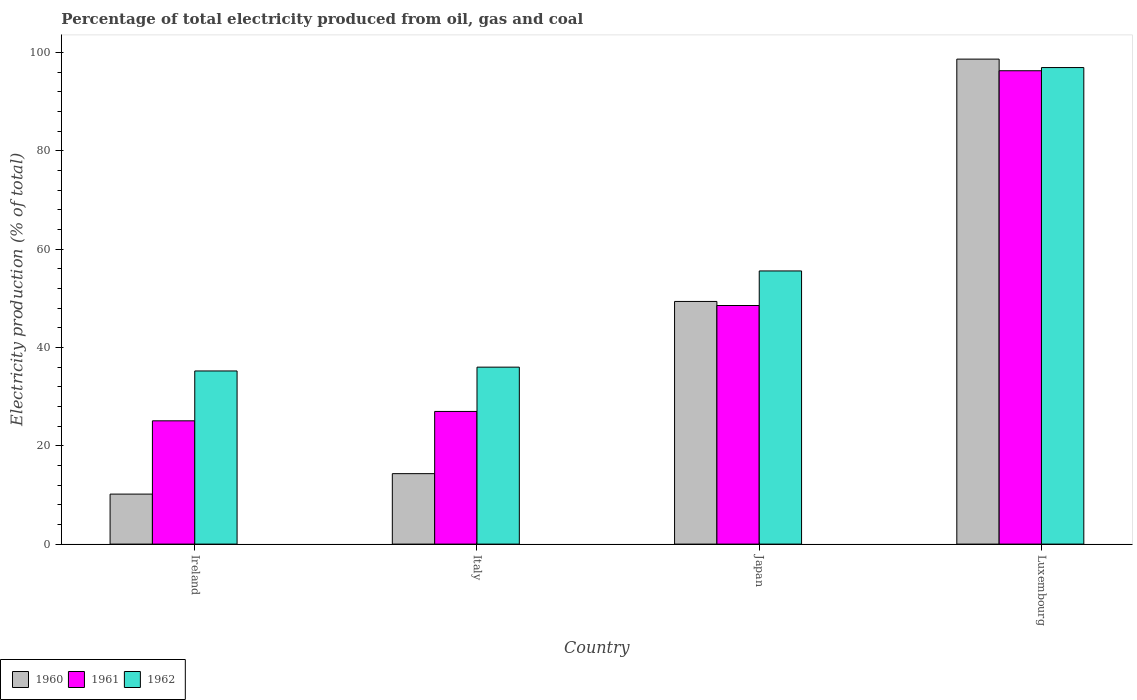How many different coloured bars are there?
Ensure brevity in your answer.  3. How many groups of bars are there?
Make the answer very short. 4. Are the number of bars on each tick of the X-axis equal?
Provide a short and direct response. Yes. What is the electricity production in in 1962 in Luxembourg?
Give a very brief answer. 96.92. Across all countries, what is the maximum electricity production in in 1961?
Your answer should be very brief. 96.27. Across all countries, what is the minimum electricity production in in 1961?
Make the answer very short. 25.07. In which country was the electricity production in in 1962 maximum?
Ensure brevity in your answer.  Luxembourg. In which country was the electricity production in in 1961 minimum?
Give a very brief answer. Ireland. What is the total electricity production in in 1960 in the graph?
Make the answer very short. 172.48. What is the difference between the electricity production in in 1961 in Ireland and that in Luxembourg?
Offer a terse response. -71.2. What is the difference between the electricity production in in 1960 in Japan and the electricity production in in 1961 in Ireland?
Ensure brevity in your answer.  24.28. What is the average electricity production in in 1962 per country?
Keep it short and to the point. 55.92. What is the difference between the electricity production in of/in 1961 and electricity production in of/in 1962 in Ireland?
Your response must be concise. -10.14. In how many countries, is the electricity production in in 1962 greater than 44 %?
Provide a succinct answer. 2. What is the ratio of the electricity production in in 1962 in Ireland to that in Luxembourg?
Keep it short and to the point. 0.36. Is the electricity production in in 1960 in Ireland less than that in Luxembourg?
Provide a short and direct response. Yes. What is the difference between the highest and the second highest electricity production in in 1962?
Make the answer very short. 60.93. What is the difference between the highest and the lowest electricity production in in 1960?
Provide a short and direct response. 88.47. Is the sum of the electricity production in in 1960 in Italy and Japan greater than the maximum electricity production in in 1961 across all countries?
Provide a short and direct response. No. What does the 3rd bar from the left in Luxembourg represents?
Your answer should be compact. 1962. What does the 3rd bar from the right in Luxembourg represents?
Ensure brevity in your answer.  1960. Are all the bars in the graph horizontal?
Your response must be concise. No. Does the graph contain grids?
Offer a very short reply. No. What is the title of the graph?
Provide a succinct answer. Percentage of total electricity produced from oil, gas and coal. Does "1972" appear as one of the legend labels in the graph?
Offer a terse response. No. What is the label or title of the Y-axis?
Provide a short and direct response. Electricity production (% of total). What is the Electricity production (% of total) in 1960 in Ireland?
Your answer should be very brief. 10.17. What is the Electricity production (% of total) of 1961 in Ireland?
Provide a short and direct response. 25.07. What is the Electricity production (% of total) in 1962 in Ireland?
Your answer should be compact. 35.21. What is the Electricity production (% of total) of 1960 in Italy?
Make the answer very short. 14.33. What is the Electricity production (% of total) in 1961 in Italy?
Make the answer very short. 26.98. What is the Electricity production (% of total) in 1962 in Italy?
Give a very brief answer. 35.99. What is the Electricity production (% of total) in 1960 in Japan?
Offer a terse response. 49.35. What is the Electricity production (% of total) of 1961 in Japan?
Provide a succinct answer. 48.52. What is the Electricity production (% of total) in 1962 in Japan?
Your response must be concise. 55.56. What is the Electricity production (% of total) in 1960 in Luxembourg?
Your answer should be compact. 98.63. What is the Electricity production (% of total) of 1961 in Luxembourg?
Ensure brevity in your answer.  96.27. What is the Electricity production (% of total) of 1962 in Luxembourg?
Offer a very short reply. 96.92. Across all countries, what is the maximum Electricity production (% of total) of 1960?
Make the answer very short. 98.63. Across all countries, what is the maximum Electricity production (% of total) of 1961?
Your answer should be very brief. 96.27. Across all countries, what is the maximum Electricity production (% of total) in 1962?
Keep it short and to the point. 96.92. Across all countries, what is the minimum Electricity production (% of total) in 1960?
Your answer should be very brief. 10.17. Across all countries, what is the minimum Electricity production (% of total) of 1961?
Offer a terse response. 25.07. Across all countries, what is the minimum Electricity production (% of total) of 1962?
Offer a very short reply. 35.21. What is the total Electricity production (% of total) of 1960 in the graph?
Your answer should be very brief. 172.48. What is the total Electricity production (% of total) of 1961 in the graph?
Offer a very short reply. 196.84. What is the total Electricity production (% of total) of 1962 in the graph?
Ensure brevity in your answer.  223.67. What is the difference between the Electricity production (% of total) of 1960 in Ireland and that in Italy?
Keep it short and to the point. -4.16. What is the difference between the Electricity production (% of total) in 1961 in Ireland and that in Italy?
Offer a very short reply. -1.91. What is the difference between the Electricity production (% of total) of 1962 in Ireland and that in Italy?
Your response must be concise. -0.78. What is the difference between the Electricity production (% of total) in 1960 in Ireland and that in Japan?
Give a very brief answer. -39.18. What is the difference between the Electricity production (% of total) in 1961 in Ireland and that in Japan?
Give a very brief answer. -23.45. What is the difference between the Electricity production (% of total) in 1962 in Ireland and that in Japan?
Your answer should be compact. -20.34. What is the difference between the Electricity production (% of total) in 1960 in Ireland and that in Luxembourg?
Provide a succinct answer. -88.47. What is the difference between the Electricity production (% of total) in 1961 in Ireland and that in Luxembourg?
Offer a terse response. -71.2. What is the difference between the Electricity production (% of total) of 1962 in Ireland and that in Luxembourg?
Your response must be concise. -61.71. What is the difference between the Electricity production (% of total) in 1960 in Italy and that in Japan?
Provide a succinct answer. -35.02. What is the difference between the Electricity production (% of total) of 1961 in Italy and that in Japan?
Give a very brief answer. -21.55. What is the difference between the Electricity production (% of total) in 1962 in Italy and that in Japan?
Give a very brief answer. -19.57. What is the difference between the Electricity production (% of total) in 1960 in Italy and that in Luxembourg?
Provide a succinct answer. -84.31. What is the difference between the Electricity production (% of total) of 1961 in Italy and that in Luxembourg?
Make the answer very short. -69.29. What is the difference between the Electricity production (% of total) of 1962 in Italy and that in Luxembourg?
Ensure brevity in your answer.  -60.93. What is the difference between the Electricity production (% of total) of 1960 in Japan and that in Luxembourg?
Provide a succinct answer. -49.28. What is the difference between the Electricity production (% of total) of 1961 in Japan and that in Luxembourg?
Give a very brief answer. -47.75. What is the difference between the Electricity production (% of total) of 1962 in Japan and that in Luxembourg?
Your response must be concise. -41.36. What is the difference between the Electricity production (% of total) in 1960 in Ireland and the Electricity production (% of total) in 1961 in Italy?
Offer a very short reply. -16.81. What is the difference between the Electricity production (% of total) of 1960 in Ireland and the Electricity production (% of total) of 1962 in Italy?
Your answer should be very brief. -25.82. What is the difference between the Electricity production (% of total) in 1961 in Ireland and the Electricity production (% of total) in 1962 in Italy?
Your answer should be very brief. -10.92. What is the difference between the Electricity production (% of total) of 1960 in Ireland and the Electricity production (% of total) of 1961 in Japan?
Your response must be concise. -38.36. What is the difference between the Electricity production (% of total) of 1960 in Ireland and the Electricity production (% of total) of 1962 in Japan?
Offer a terse response. -45.39. What is the difference between the Electricity production (% of total) of 1961 in Ireland and the Electricity production (% of total) of 1962 in Japan?
Your answer should be compact. -30.48. What is the difference between the Electricity production (% of total) of 1960 in Ireland and the Electricity production (% of total) of 1961 in Luxembourg?
Your answer should be very brief. -86.1. What is the difference between the Electricity production (% of total) of 1960 in Ireland and the Electricity production (% of total) of 1962 in Luxembourg?
Your response must be concise. -86.75. What is the difference between the Electricity production (% of total) of 1961 in Ireland and the Electricity production (% of total) of 1962 in Luxembourg?
Your response must be concise. -71.85. What is the difference between the Electricity production (% of total) of 1960 in Italy and the Electricity production (% of total) of 1961 in Japan?
Provide a succinct answer. -34.2. What is the difference between the Electricity production (% of total) of 1960 in Italy and the Electricity production (% of total) of 1962 in Japan?
Give a very brief answer. -41.23. What is the difference between the Electricity production (% of total) in 1961 in Italy and the Electricity production (% of total) in 1962 in Japan?
Make the answer very short. -28.58. What is the difference between the Electricity production (% of total) in 1960 in Italy and the Electricity production (% of total) in 1961 in Luxembourg?
Provide a short and direct response. -81.94. What is the difference between the Electricity production (% of total) in 1960 in Italy and the Electricity production (% of total) in 1962 in Luxembourg?
Provide a succinct answer. -82.59. What is the difference between the Electricity production (% of total) in 1961 in Italy and the Electricity production (% of total) in 1962 in Luxembourg?
Your answer should be compact. -69.94. What is the difference between the Electricity production (% of total) in 1960 in Japan and the Electricity production (% of total) in 1961 in Luxembourg?
Give a very brief answer. -46.92. What is the difference between the Electricity production (% of total) in 1960 in Japan and the Electricity production (% of total) in 1962 in Luxembourg?
Give a very brief answer. -47.57. What is the difference between the Electricity production (% of total) in 1961 in Japan and the Electricity production (% of total) in 1962 in Luxembourg?
Keep it short and to the point. -48.39. What is the average Electricity production (% of total) in 1960 per country?
Your response must be concise. 43.12. What is the average Electricity production (% of total) in 1961 per country?
Provide a short and direct response. 49.21. What is the average Electricity production (% of total) of 1962 per country?
Provide a succinct answer. 55.92. What is the difference between the Electricity production (% of total) in 1960 and Electricity production (% of total) in 1961 in Ireland?
Give a very brief answer. -14.9. What is the difference between the Electricity production (% of total) of 1960 and Electricity production (% of total) of 1962 in Ireland?
Your answer should be compact. -25.04. What is the difference between the Electricity production (% of total) of 1961 and Electricity production (% of total) of 1962 in Ireland?
Your response must be concise. -10.14. What is the difference between the Electricity production (% of total) in 1960 and Electricity production (% of total) in 1961 in Italy?
Ensure brevity in your answer.  -12.65. What is the difference between the Electricity production (% of total) of 1960 and Electricity production (% of total) of 1962 in Italy?
Your answer should be compact. -21.66. What is the difference between the Electricity production (% of total) of 1961 and Electricity production (% of total) of 1962 in Italy?
Your answer should be very brief. -9.01. What is the difference between the Electricity production (% of total) in 1960 and Electricity production (% of total) in 1961 in Japan?
Provide a short and direct response. 0.83. What is the difference between the Electricity production (% of total) of 1960 and Electricity production (% of total) of 1962 in Japan?
Your answer should be compact. -6.2. What is the difference between the Electricity production (% of total) in 1961 and Electricity production (% of total) in 1962 in Japan?
Give a very brief answer. -7.03. What is the difference between the Electricity production (% of total) in 1960 and Electricity production (% of total) in 1961 in Luxembourg?
Give a very brief answer. 2.36. What is the difference between the Electricity production (% of total) in 1960 and Electricity production (% of total) in 1962 in Luxembourg?
Your answer should be very brief. 1.72. What is the difference between the Electricity production (% of total) of 1961 and Electricity production (% of total) of 1962 in Luxembourg?
Make the answer very short. -0.65. What is the ratio of the Electricity production (% of total) in 1960 in Ireland to that in Italy?
Provide a succinct answer. 0.71. What is the ratio of the Electricity production (% of total) of 1961 in Ireland to that in Italy?
Your response must be concise. 0.93. What is the ratio of the Electricity production (% of total) in 1962 in Ireland to that in Italy?
Offer a very short reply. 0.98. What is the ratio of the Electricity production (% of total) of 1960 in Ireland to that in Japan?
Make the answer very short. 0.21. What is the ratio of the Electricity production (% of total) in 1961 in Ireland to that in Japan?
Your response must be concise. 0.52. What is the ratio of the Electricity production (% of total) of 1962 in Ireland to that in Japan?
Ensure brevity in your answer.  0.63. What is the ratio of the Electricity production (% of total) of 1960 in Ireland to that in Luxembourg?
Keep it short and to the point. 0.1. What is the ratio of the Electricity production (% of total) in 1961 in Ireland to that in Luxembourg?
Ensure brevity in your answer.  0.26. What is the ratio of the Electricity production (% of total) in 1962 in Ireland to that in Luxembourg?
Your answer should be compact. 0.36. What is the ratio of the Electricity production (% of total) in 1960 in Italy to that in Japan?
Provide a short and direct response. 0.29. What is the ratio of the Electricity production (% of total) of 1961 in Italy to that in Japan?
Offer a very short reply. 0.56. What is the ratio of the Electricity production (% of total) in 1962 in Italy to that in Japan?
Keep it short and to the point. 0.65. What is the ratio of the Electricity production (% of total) in 1960 in Italy to that in Luxembourg?
Keep it short and to the point. 0.15. What is the ratio of the Electricity production (% of total) of 1961 in Italy to that in Luxembourg?
Offer a terse response. 0.28. What is the ratio of the Electricity production (% of total) in 1962 in Italy to that in Luxembourg?
Give a very brief answer. 0.37. What is the ratio of the Electricity production (% of total) in 1960 in Japan to that in Luxembourg?
Give a very brief answer. 0.5. What is the ratio of the Electricity production (% of total) of 1961 in Japan to that in Luxembourg?
Keep it short and to the point. 0.5. What is the ratio of the Electricity production (% of total) of 1962 in Japan to that in Luxembourg?
Offer a very short reply. 0.57. What is the difference between the highest and the second highest Electricity production (% of total) of 1960?
Provide a short and direct response. 49.28. What is the difference between the highest and the second highest Electricity production (% of total) in 1961?
Provide a short and direct response. 47.75. What is the difference between the highest and the second highest Electricity production (% of total) of 1962?
Ensure brevity in your answer.  41.36. What is the difference between the highest and the lowest Electricity production (% of total) in 1960?
Your answer should be very brief. 88.47. What is the difference between the highest and the lowest Electricity production (% of total) of 1961?
Your answer should be compact. 71.2. What is the difference between the highest and the lowest Electricity production (% of total) in 1962?
Provide a short and direct response. 61.71. 